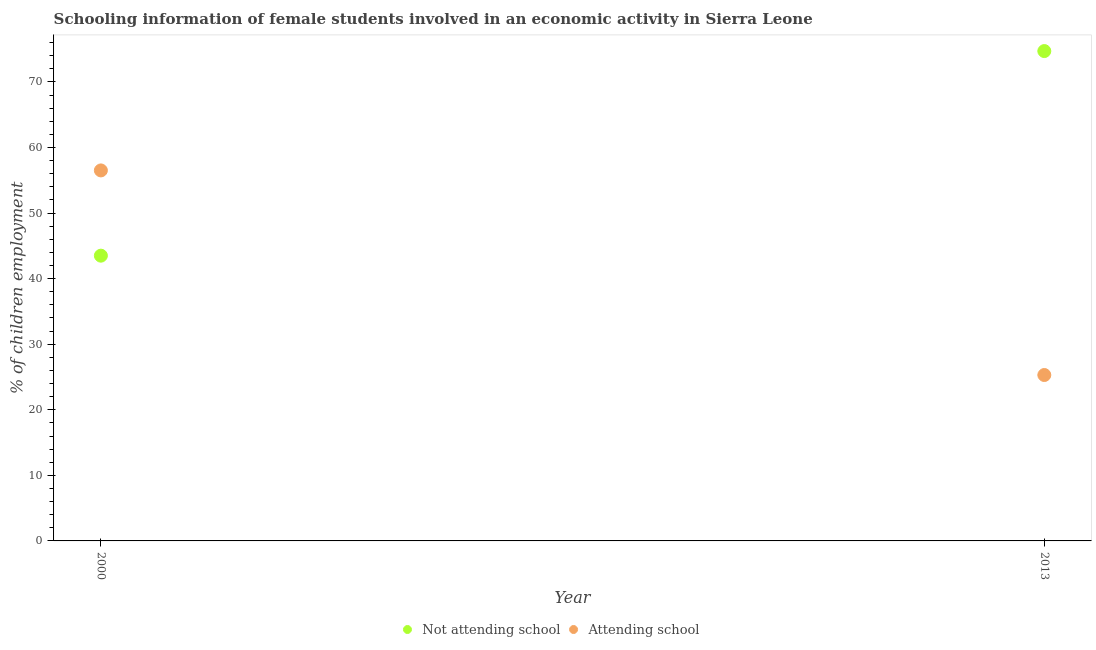How many different coloured dotlines are there?
Make the answer very short. 2. What is the percentage of employed females who are attending school in 2000?
Give a very brief answer. 56.5. Across all years, what is the maximum percentage of employed females who are not attending school?
Your answer should be very brief. 74.7. Across all years, what is the minimum percentage of employed females who are not attending school?
Give a very brief answer. 43.5. In which year was the percentage of employed females who are attending school maximum?
Provide a succinct answer. 2000. In which year was the percentage of employed females who are attending school minimum?
Your answer should be very brief. 2013. What is the total percentage of employed females who are attending school in the graph?
Make the answer very short. 81.8. What is the difference between the percentage of employed females who are attending school in 2000 and that in 2013?
Your answer should be compact. 31.2. What is the difference between the percentage of employed females who are not attending school in 2013 and the percentage of employed females who are attending school in 2000?
Your answer should be compact. 18.2. What is the average percentage of employed females who are attending school per year?
Give a very brief answer. 40.9. What is the ratio of the percentage of employed females who are attending school in 2000 to that in 2013?
Offer a terse response. 2.23. Is the percentage of employed females who are not attending school in 2000 less than that in 2013?
Your answer should be very brief. Yes. Is the percentage of employed females who are attending school strictly greater than the percentage of employed females who are not attending school over the years?
Make the answer very short. No. Is the percentage of employed females who are not attending school strictly less than the percentage of employed females who are attending school over the years?
Keep it short and to the point. No. How many dotlines are there?
Make the answer very short. 2. How many years are there in the graph?
Make the answer very short. 2. What is the difference between two consecutive major ticks on the Y-axis?
Provide a succinct answer. 10. Does the graph contain any zero values?
Provide a short and direct response. No. Where does the legend appear in the graph?
Your answer should be compact. Bottom center. What is the title of the graph?
Your answer should be very brief. Schooling information of female students involved in an economic activity in Sierra Leone. Does "Excluding technical cooperation" appear as one of the legend labels in the graph?
Offer a very short reply. No. What is the label or title of the X-axis?
Keep it short and to the point. Year. What is the label or title of the Y-axis?
Keep it short and to the point. % of children employment. What is the % of children employment in Not attending school in 2000?
Your answer should be very brief. 43.5. What is the % of children employment of Attending school in 2000?
Offer a terse response. 56.5. What is the % of children employment in Not attending school in 2013?
Ensure brevity in your answer.  74.7. What is the % of children employment in Attending school in 2013?
Keep it short and to the point. 25.3. Across all years, what is the maximum % of children employment in Not attending school?
Make the answer very short. 74.7. Across all years, what is the maximum % of children employment of Attending school?
Give a very brief answer. 56.5. Across all years, what is the minimum % of children employment of Not attending school?
Ensure brevity in your answer.  43.5. Across all years, what is the minimum % of children employment in Attending school?
Keep it short and to the point. 25.3. What is the total % of children employment of Not attending school in the graph?
Keep it short and to the point. 118.2. What is the total % of children employment of Attending school in the graph?
Ensure brevity in your answer.  81.8. What is the difference between the % of children employment of Not attending school in 2000 and that in 2013?
Provide a short and direct response. -31.2. What is the difference between the % of children employment in Attending school in 2000 and that in 2013?
Your answer should be compact. 31.2. What is the average % of children employment of Not attending school per year?
Keep it short and to the point. 59.1. What is the average % of children employment of Attending school per year?
Provide a short and direct response. 40.9. In the year 2013, what is the difference between the % of children employment of Not attending school and % of children employment of Attending school?
Offer a terse response. 49.4. What is the ratio of the % of children employment of Not attending school in 2000 to that in 2013?
Make the answer very short. 0.58. What is the ratio of the % of children employment in Attending school in 2000 to that in 2013?
Your answer should be compact. 2.23. What is the difference between the highest and the second highest % of children employment of Not attending school?
Provide a short and direct response. 31.2. What is the difference between the highest and the second highest % of children employment of Attending school?
Offer a terse response. 31.2. What is the difference between the highest and the lowest % of children employment in Not attending school?
Make the answer very short. 31.2. What is the difference between the highest and the lowest % of children employment in Attending school?
Offer a very short reply. 31.2. 